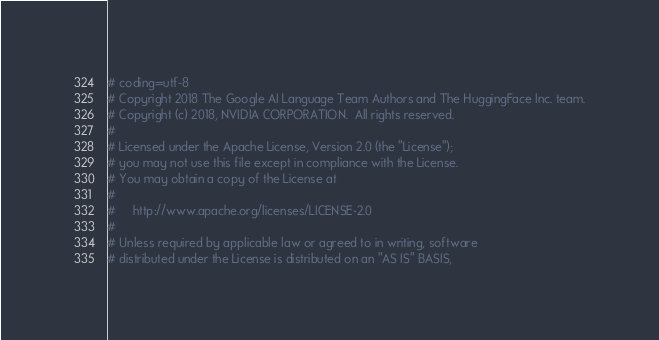<code> <loc_0><loc_0><loc_500><loc_500><_Python_># coding=utf-8
# Copyright 2018 The Google AI Language Team Authors and The HuggingFace Inc. team.
# Copyright (c) 2018, NVIDIA CORPORATION.  All rights reserved.
#
# Licensed under the Apache License, Version 2.0 (the "License");
# you may not use this file except in compliance with the License.
# You may obtain a copy of the License at
#
#     http://www.apache.org/licenses/LICENSE-2.0
#
# Unless required by applicable law or agreed to in writing, software
# distributed under the License is distributed on an "AS IS" BASIS,</code> 